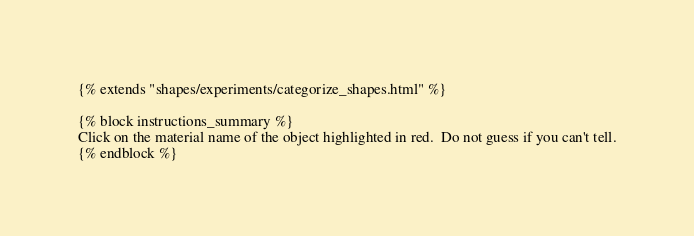Convert code to text. <code><loc_0><loc_0><loc_500><loc_500><_HTML_>{% extends "shapes/experiments/categorize_shapes.html" %}

{% block instructions_summary %}
Click on the material name of the object highlighted in red.  Do not guess if you can't tell.
{% endblock %}
</code> 